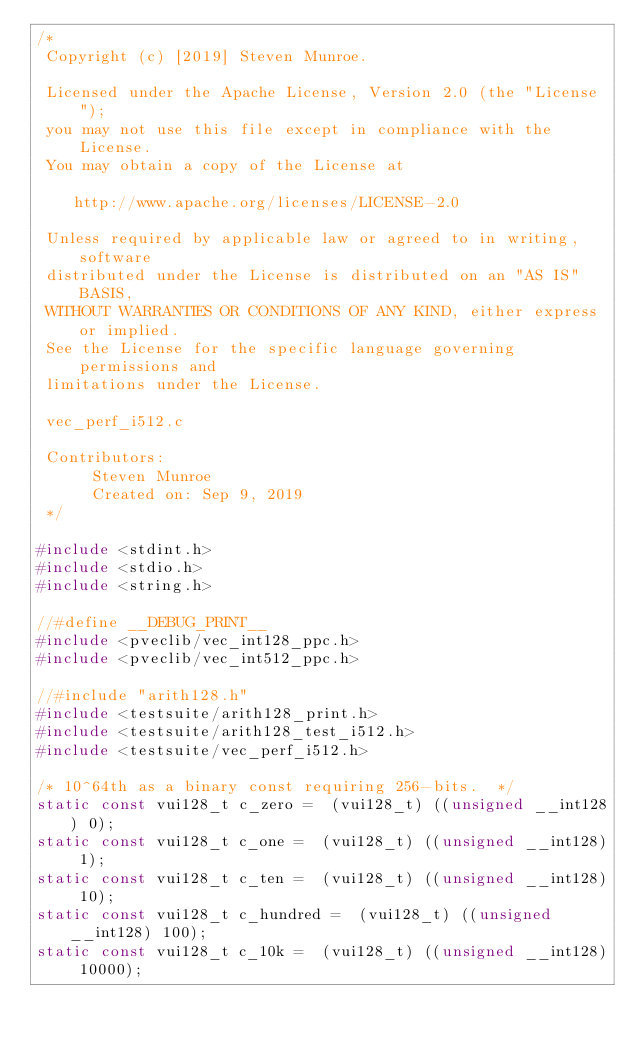Convert code to text. <code><loc_0><loc_0><loc_500><loc_500><_C_>/*
 Copyright (c) [2019] Steven Munroe.

 Licensed under the Apache License, Version 2.0 (the "License");
 you may not use this file except in compliance with the License.
 You may obtain a copy of the License at

    http://www.apache.org/licenses/LICENSE-2.0

 Unless required by applicable law or agreed to in writing, software
 distributed under the License is distributed on an "AS IS" BASIS,
 WITHOUT WARRANTIES OR CONDITIONS OF ANY KIND, either express or implied.
 See the License for the specific language governing permissions and
 limitations under the License.

 vec_perf_i512.c

 Contributors:
      Steven Munroe
      Created on: Sep 9, 2019
 */

#include <stdint.h>
#include <stdio.h>
#include <string.h>

//#define __DEBUG_PRINT__
#include <pveclib/vec_int128_ppc.h>
#include <pveclib/vec_int512_ppc.h>

//#include "arith128.h"
#include <testsuite/arith128_print.h>
#include <testsuite/arith128_test_i512.h>
#include <testsuite/vec_perf_i512.h>

/* 10^64th as a binary const requiring 256-bits.  */
static const vui128_t c_zero =  (vui128_t) ((unsigned __int128) 0);
static const vui128_t c_one =  (vui128_t) ((unsigned __int128) 1);
static const vui128_t c_ten =  (vui128_t) ((unsigned __int128) 10);
static const vui128_t c_hundred =  (vui128_t) ((unsigned __int128) 100);
static const vui128_t c_10k =  (vui128_t) ((unsigned __int128) 10000);</code> 